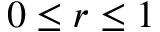Convert formula to latex. <formula><loc_0><loc_0><loc_500><loc_500>0 \leq r \leq 1</formula> 